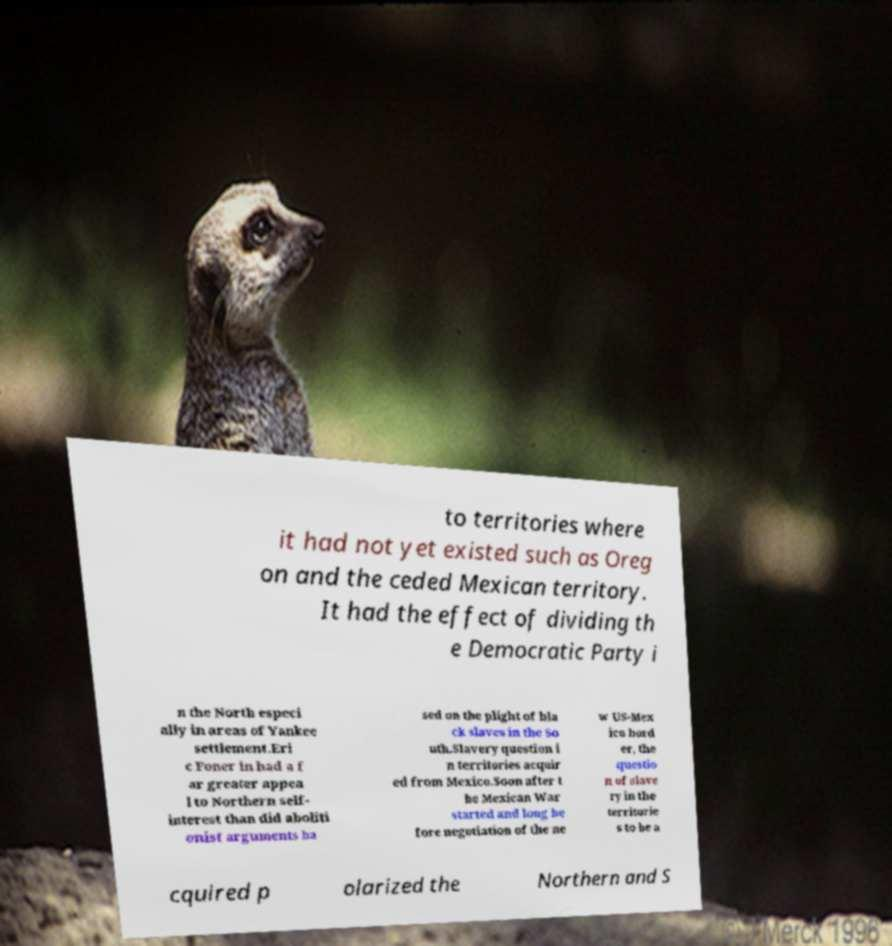Can you accurately transcribe the text from the provided image for me? to territories where it had not yet existed such as Oreg on and the ceded Mexican territory. It had the effect of dividing th e Democratic Party i n the North especi ally in areas of Yankee settlement.Eri c Foner in had a f ar greater appea l to Northern self- interest than did aboliti onist arguments ba sed on the plight of bla ck slaves in the So uth.Slavery question i n territories acquir ed from Mexico.Soon after t he Mexican War started and long be fore negotiation of the ne w US-Mex ico bord er, the questio n of slave ry in the territorie s to be a cquired p olarized the Northern and S 